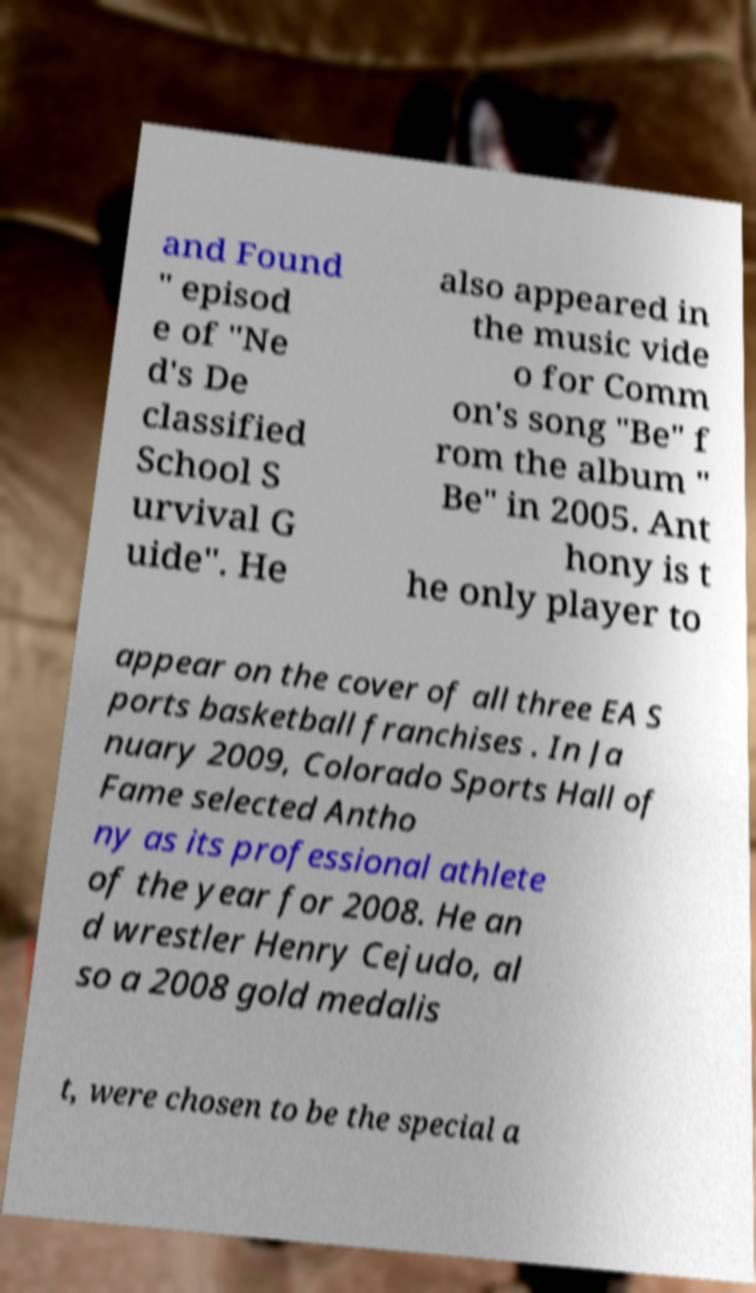Can you accurately transcribe the text from the provided image for me? and Found " episod e of "Ne d's De classified School S urvival G uide". He also appeared in the music vide o for Comm on's song "Be" f rom the album " Be" in 2005. Ant hony is t he only player to appear on the cover of all three EA S ports basketball franchises . In Ja nuary 2009, Colorado Sports Hall of Fame selected Antho ny as its professional athlete of the year for 2008. He an d wrestler Henry Cejudo, al so a 2008 gold medalis t, were chosen to be the special a 